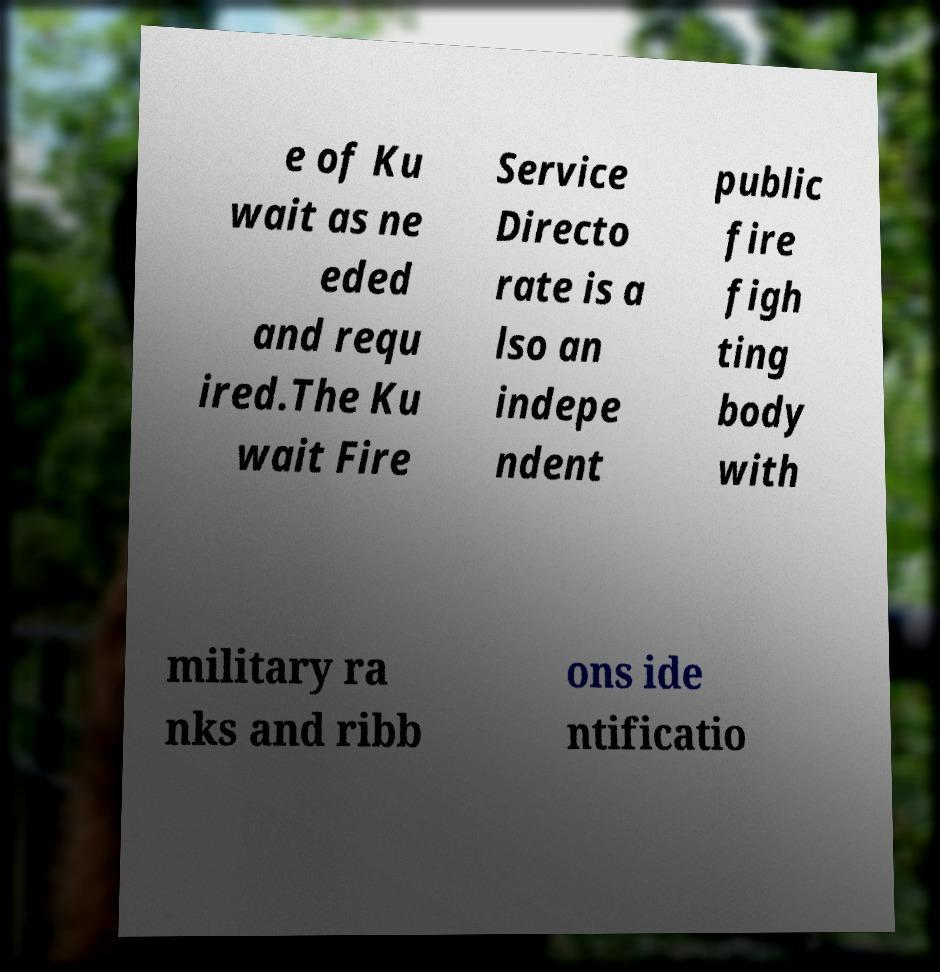Can you read and provide the text displayed in the image?This photo seems to have some interesting text. Can you extract and type it out for me? e of Ku wait as ne eded and requ ired.The Ku wait Fire Service Directo rate is a lso an indepe ndent public fire figh ting body with military ra nks and ribb ons ide ntificatio 